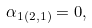<formula> <loc_0><loc_0><loc_500><loc_500>\alpha _ { 1 \left ( 2 , 1 \right ) } = 0 ,</formula> 